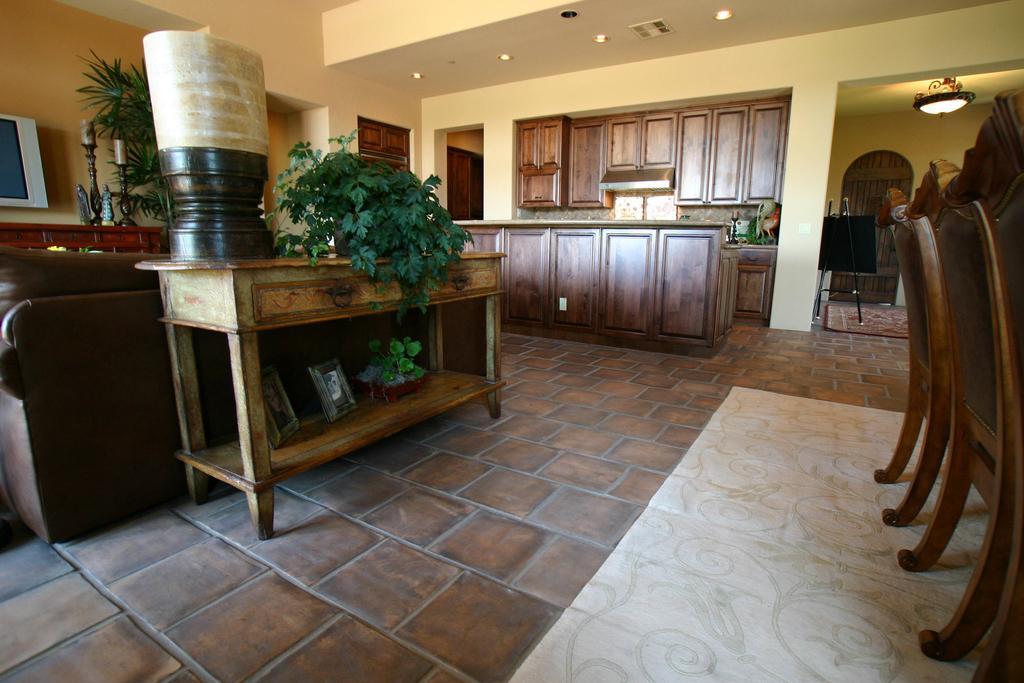Describe this image in one or two sentences. In this image there is a wooden table and on top of it there are flower pots, photo frames and some object. Behind the table there is a sofa. Behind the sofa there is a wooden table and on top of it there are few objects. On the right side of the image there are chairs. At the bottom of the image there is a mat. On top of the image there are lights. There are wooden cupboards. There is a platform and on top of it there are few objects. 